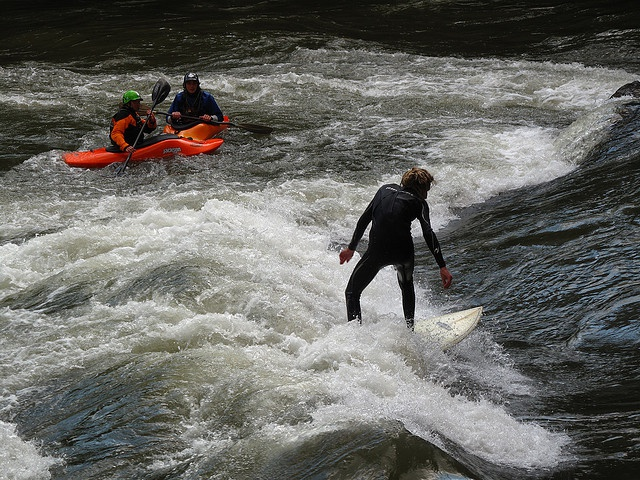Describe the objects in this image and their specific colors. I can see people in black, gray, darkgray, and maroon tones, boat in black, maroon, and red tones, people in black, gray, maroon, and navy tones, people in black, maroon, and darkgreen tones, and surfboard in black, darkgray, lightgray, and gray tones in this image. 